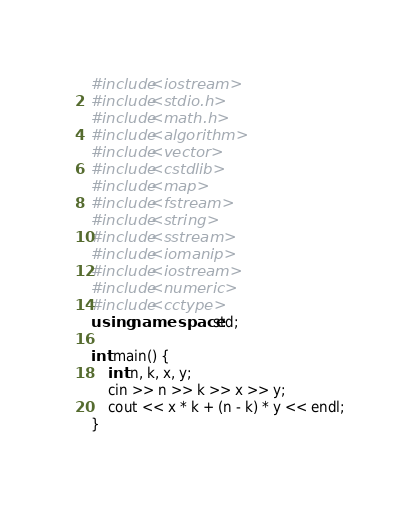<code> <loc_0><loc_0><loc_500><loc_500><_C++_>#include<iostream>
#include<stdio.h>
#include<math.h>
#include<algorithm>
#include<vector>
#include<cstdlib>
#include<map>
#include<fstream>
#include<string>
#include<sstream>
#include<iomanip>
#include<iostream>
#include<numeric>
#include<cctype>
using namespace std;

int main() {
	int n, k, x, y;
	cin >> n >> k >> x >> y;
	cout << x * k + (n - k) * y << endl;
}
</code> 